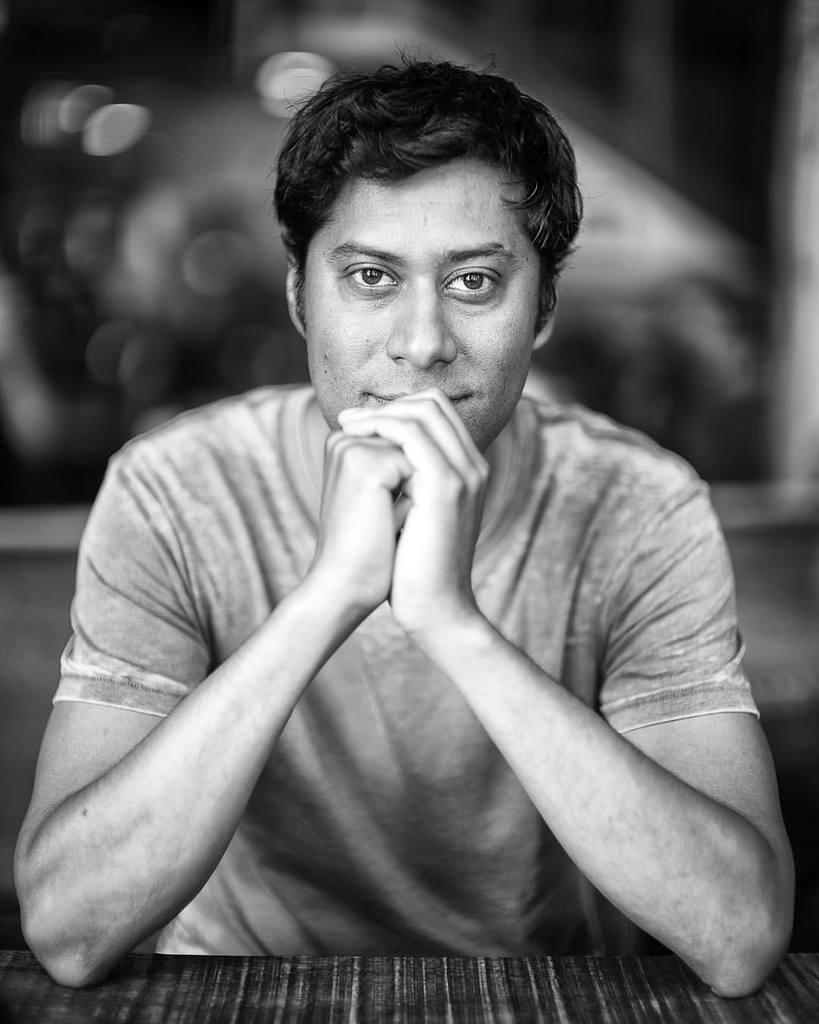What is the man in the image doing? The man is sitting in the image. What can be observed about the man's attire? The man is wearing clothes. What is the man's facial expression in the image? The man is smiling. Can you describe the background of the image? The background of the image is blurred. What type of oven is being used by the man in the image? There is no oven present in the image; it features a man sitting and smiling. 